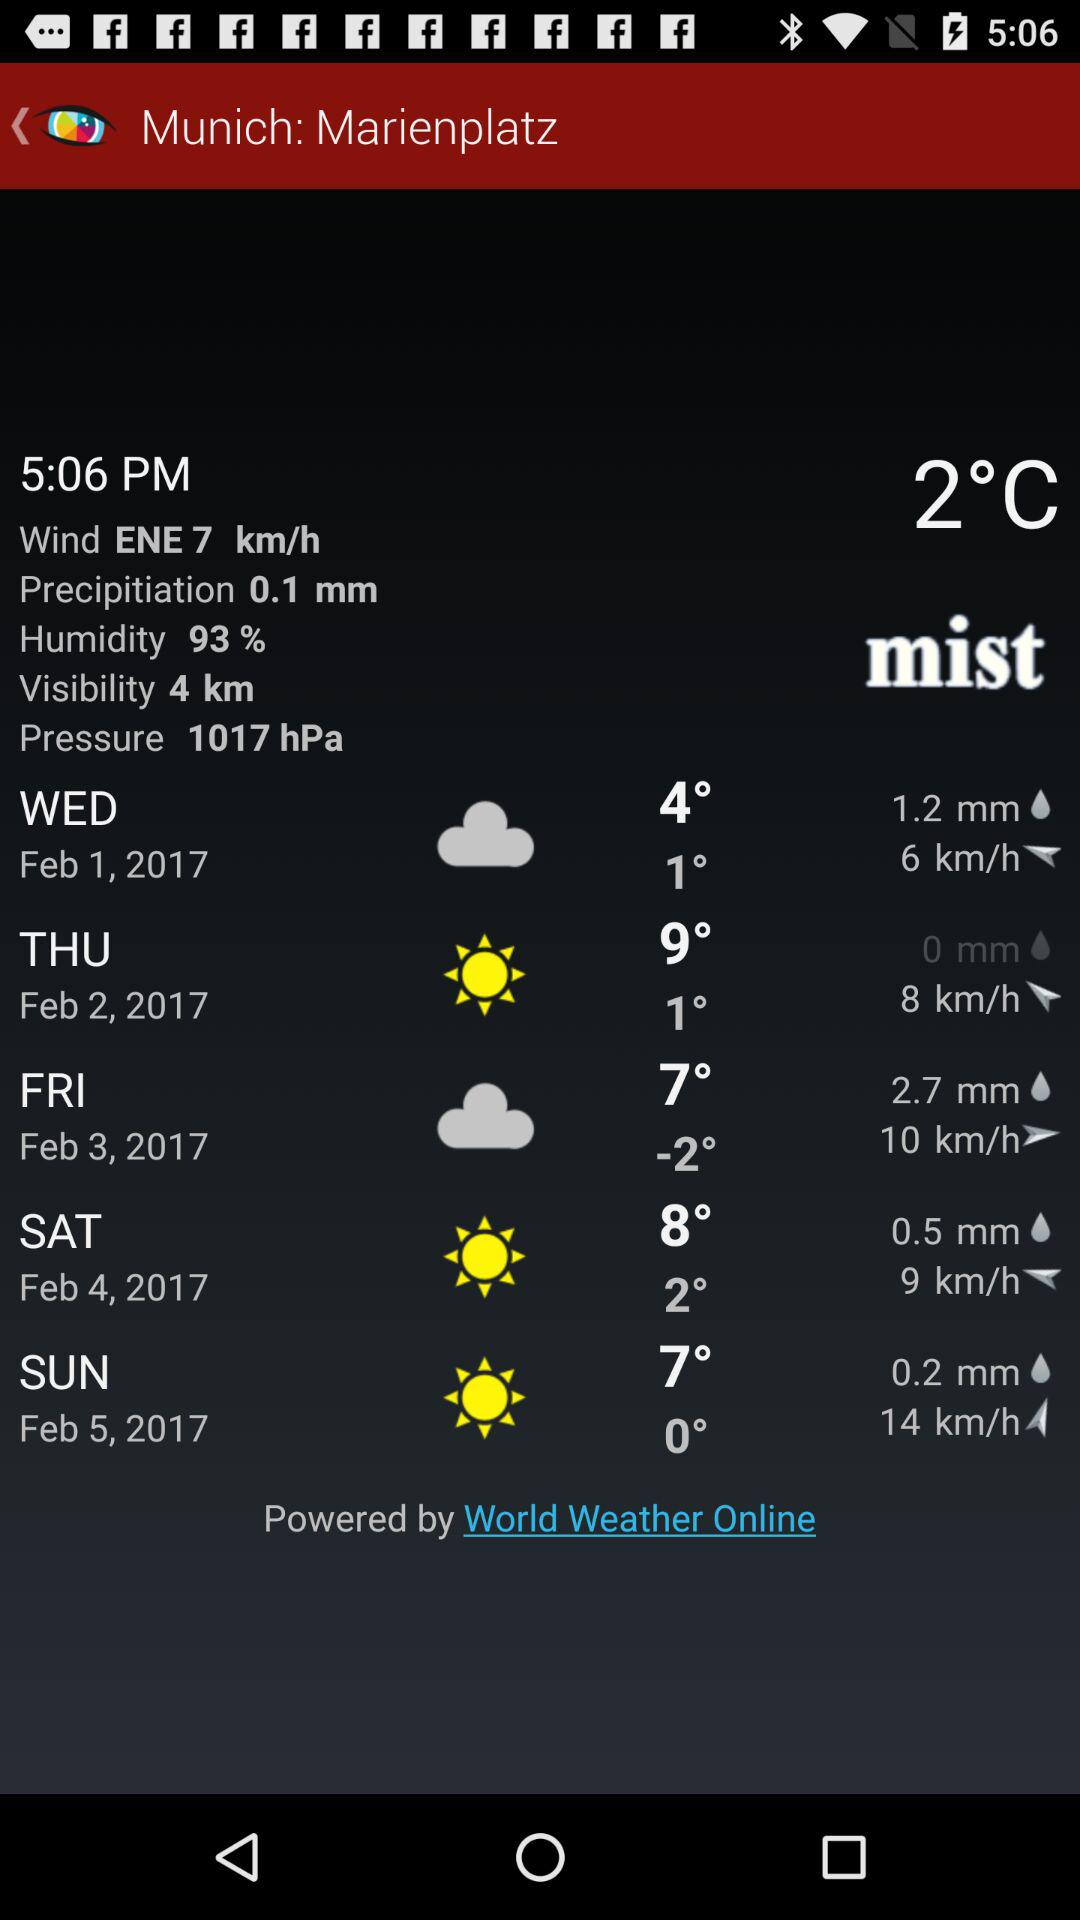What is the pressure? The pressure is 1017 hPa. 